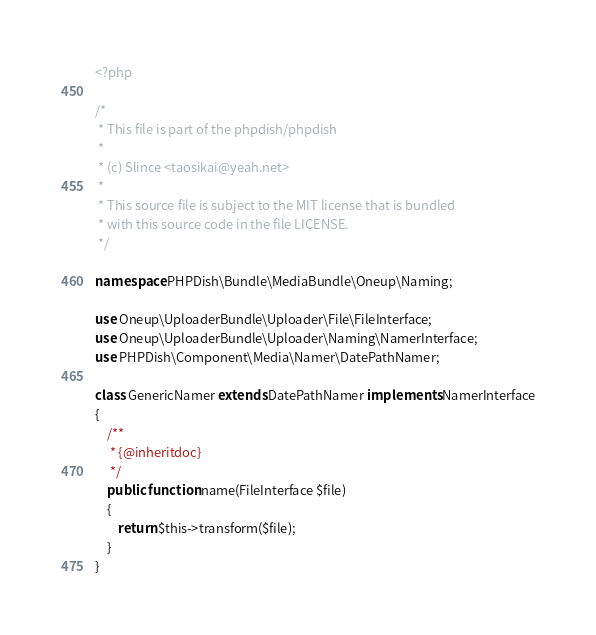<code> <loc_0><loc_0><loc_500><loc_500><_PHP_><?php

/*
 * This file is part of the phpdish/phpdish
 *
 * (c) Slince <taosikai@yeah.net>
 *
 * This source file is subject to the MIT license that is bundled
 * with this source code in the file LICENSE.
 */

namespace PHPDish\Bundle\MediaBundle\Oneup\Naming;

use Oneup\UploaderBundle\Uploader\File\FileInterface;
use Oneup\UploaderBundle\Uploader\Naming\NamerInterface;
use PHPDish\Component\Media\Namer\DatePathNamer;

class GenericNamer extends DatePathNamer implements NamerInterface
{
    /**
     * {@inheritdoc}
     */
    public function name(FileInterface $file)
    {
        return $this->transform($file);
    }
}</code> 